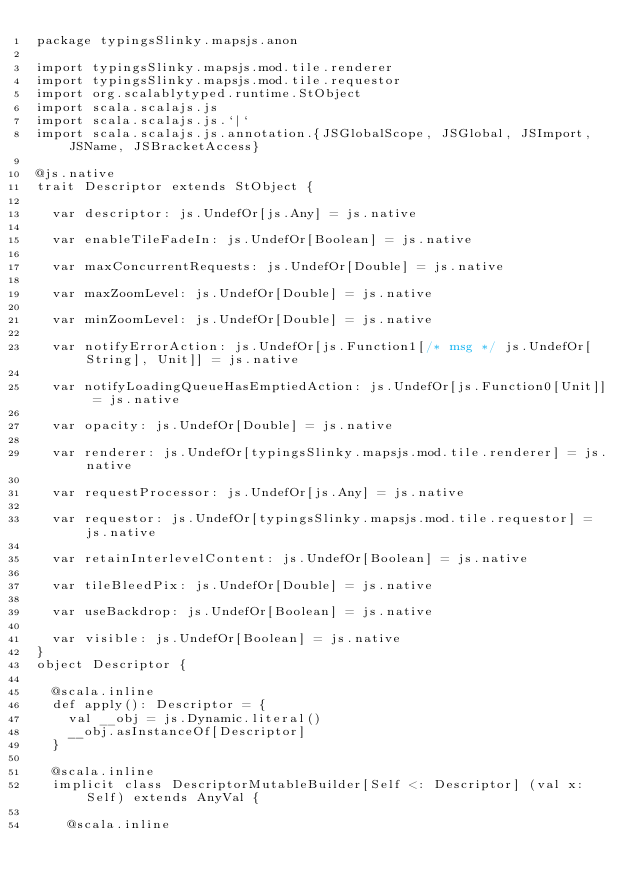Convert code to text. <code><loc_0><loc_0><loc_500><loc_500><_Scala_>package typingsSlinky.mapsjs.anon

import typingsSlinky.mapsjs.mod.tile.renderer
import typingsSlinky.mapsjs.mod.tile.requestor
import org.scalablytyped.runtime.StObject
import scala.scalajs.js
import scala.scalajs.js.`|`
import scala.scalajs.js.annotation.{JSGlobalScope, JSGlobal, JSImport, JSName, JSBracketAccess}

@js.native
trait Descriptor extends StObject {
  
  var descriptor: js.UndefOr[js.Any] = js.native
  
  var enableTileFadeIn: js.UndefOr[Boolean] = js.native
  
  var maxConcurrentRequests: js.UndefOr[Double] = js.native
  
  var maxZoomLevel: js.UndefOr[Double] = js.native
  
  var minZoomLevel: js.UndefOr[Double] = js.native
  
  var notifyErrorAction: js.UndefOr[js.Function1[/* msg */ js.UndefOr[String], Unit]] = js.native
  
  var notifyLoadingQueueHasEmptiedAction: js.UndefOr[js.Function0[Unit]] = js.native
  
  var opacity: js.UndefOr[Double] = js.native
  
  var renderer: js.UndefOr[typingsSlinky.mapsjs.mod.tile.renderer] = js.native
  
  var requestProcessor: js.UndefOr[js.Any] = js.native
  
  var requestor: js.UndefOr[typingsSlinky.mapsjs.mod.tile.requestor] = js.native
  
  var retainInterlevelContent: js.UndefOr[Boolean] = js.native
  
  var tileBleedPix: js.UndefOr[Double] = js.native
  
  var useBackdrop: js.UndefOr[Boolean] = js.native
  
  var visible: js.UndefOr[Boolean] = js.native
}
object Descriptor {
  
  @scala.inline
  def apply(): Descriptor = {
    val __obj = js.Dynamic.literal()
    __obj.asInstanceOf[Descriptor]
  }
  
  @scala.inline
  implicit class DescriptorMutableBuilder[Self <: Descriptor] (val x: Self) extends AnyVal {
    
    @scala.inline</code> 